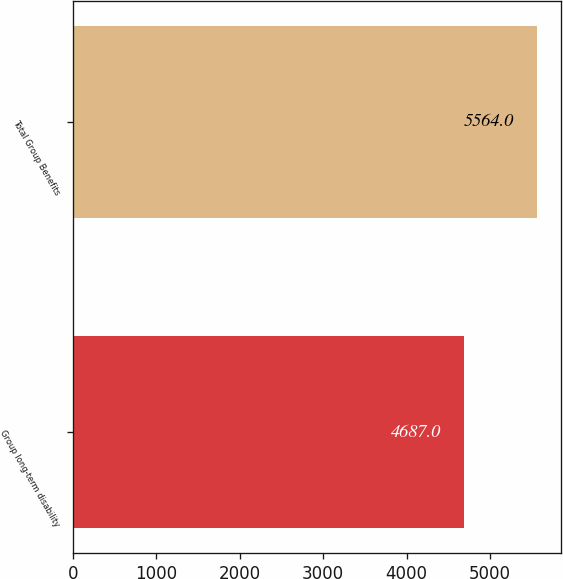<chart> <loc_0><loc_0><loc_500><loc_500><bar_chart><fcel>Group long-term disability<fcel>Total Group Benefits<nl><fcel>4687<fcel>5564<nl></chart> 